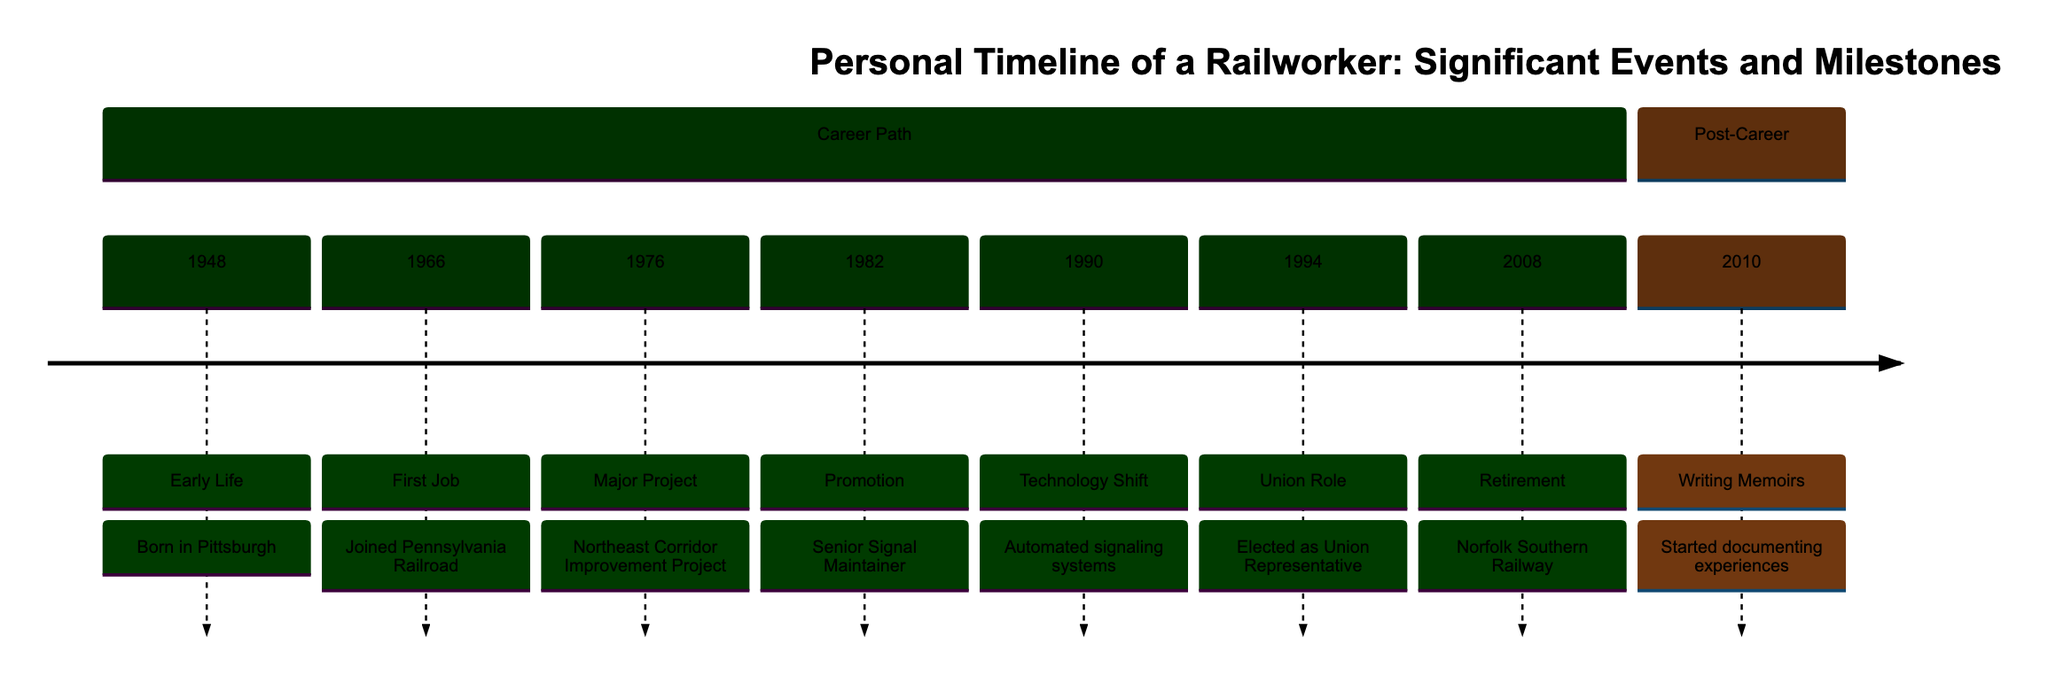What is the first significant event in the timeline? The first significant event in the timeline is "Born in Pittsburgh" in 1948. This information is found at the very beginning of the timeline under the section "Career Path."
Answer: Born in Pittsburgh How many major projects are listed in the timeline? There is one major project listed, which is the "Northeast Corridor Improvement Project" in 1976. The section "Career Path" details this project as a significant milestone.
Answer: 1 In which year did the railworker retire? The year of retirement is 2008, as shown in the timeline under the relevant section. This marks the final significant event in the "Career Path" section.
Answer: 2008 What role was the railworker elected to in 1994? The railworker was elected as "Union Representative" in 1994. This detail is specifically mentioned in the timeline within the "Career Path" section.
Answer: Union Representative What activity did the railworker start in 2010? The railworker started "Writing Memoirs" in 2010. This information is located in the "Post-Career" section of the timeline, indicating a key transition in their life.
Answer: Writing Memoirs Which event marks a technology shift in the timeline? The event that marks a technology shift is "Automated signaling systems" in 1990. It reflects a significant change in the rail industry documented in the timeline.
Answer: Automated signaling systems What position did the railworker achieve in 1982? The position achieved in 1982 is "Senior Signal Maintainer." This is explicitly mentioned in the timeline under the "Career Path" section, outlining the worker's career progression.
Answer: Senior Signal Maintainer What was the significant project that occurred before the railworker's promotion in 1982? The significant project that occurred before the 1982 promotion is the "Northeast Corridor Improvement Project" in 1976. This shows the timeline's flow where the project precedes the promotion.
Answer: Northeast Corridor Improvement Project How long did the railworker serve before retiring in 2008? The railworker served from 1966 to 2008, which totals 42 years. This is calculated by taking the difference between the two years in the timeline's "Career Path" section.
Answer: 42 years 